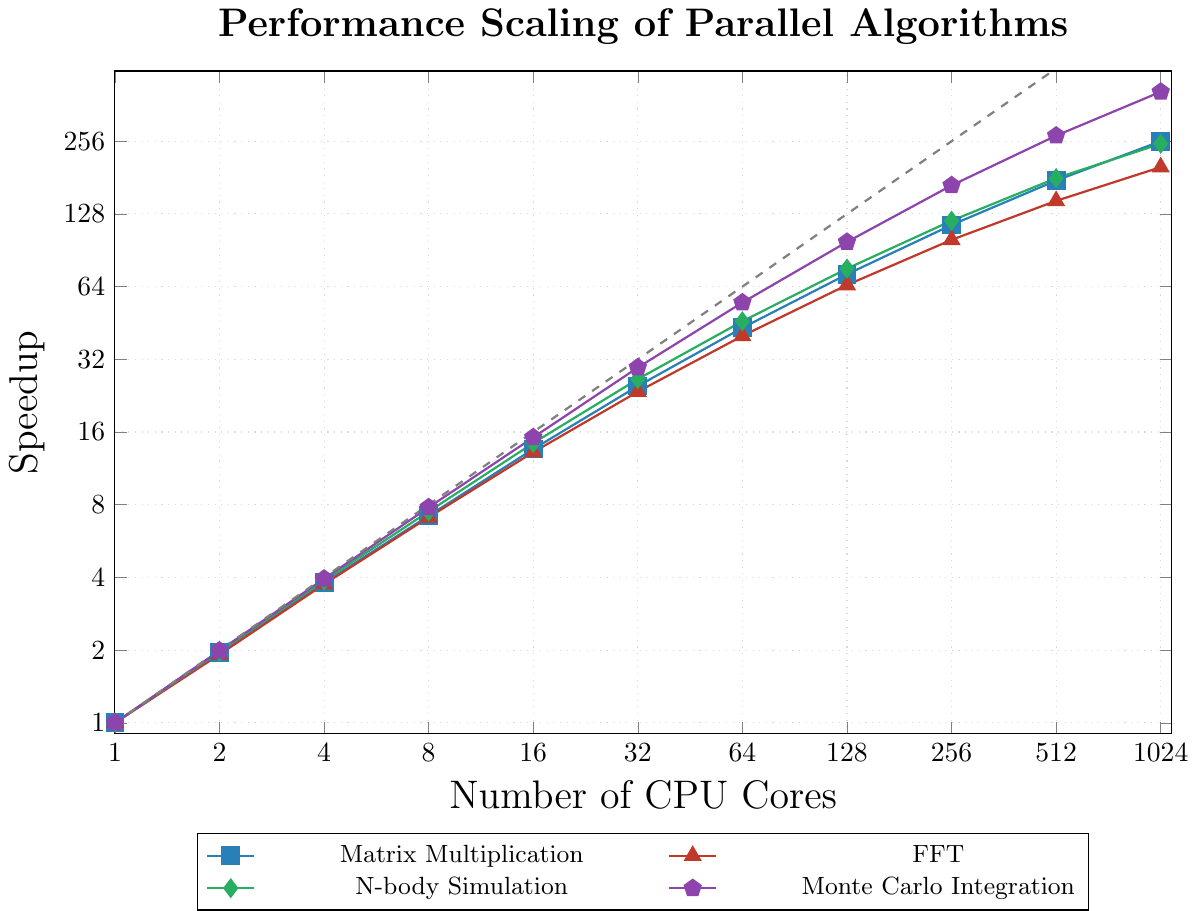What are the speedup values for Matrix Multiplication when using 8 and 64 CPU cores? Look at the Matrix Multiplication line (blue) on the plot and find the corresponding speedup values for 8 and 64 CPU cores. For 8 cores, the speedup is 7.20, and for 64 cores, it is 43.20.
Answer: 7.20 and 43.20 Which algorithm shows the highest speedup when using 512 CPU cores? Look at the plot and compare the speedup values for all four algorithms at 512 CPU cores. Monte Carlo Integration has the highest speedup with a value of 270.
Answer: Monte Carlo Integration How does the speedup of FFT compare between using 2 and 32 CPU cores? Look at the FFT line (red) on the plot. The speedup for 2 cores is 1.92, and for 32 cores is 23.50. Subtracting the two values, 23.50 - 1.92 = 21.58.
Answer: FFT speedup increases by 21.58 Which algorithm has the least efficient scaling on average from 1 to 1024 CPU cores? Compare the overall trends of the speedup lines for all four algorithms. The FFT line (red) consistently shows lower speedup values compared to the other algorithms across the range of CPU cores.
Answer: FFT At 256 CPU cores, what is the average speedup across all four algorithms? Find the speedup values for 256 cores for all four algorithms: Matrix Multiplication (115.20), FFT (100.00), N-body Simulation (120.00), and Monte Carlo Integration (168.00). Calculate the average: (115.20 + 100.00 + 120.00 + 168.00) / 4 = 125.80.
Answer: 125.80 Which algorithm's speedup curve is closest to the ideal linear speedup line at 1024 CPU cores? Observe the proximity of each algorithm's speedup value to the ideal linear speedup (dashed gray line) at 1024 CPU cores. The Matrix Multiplication speedup (256.00) is closest to the ideal linear speedup of 1024.
Answer: Matrix Multiplication 